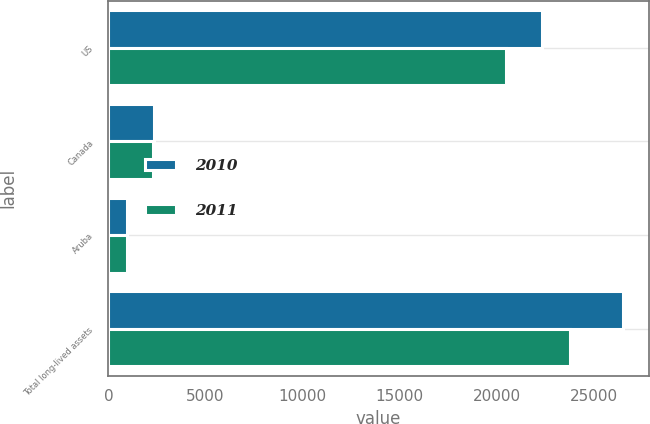<chart> <loc_0><loc_0><loc_500><loc_500><stacked_bar_chart><ecel><fcel>US<fcel>Canada<fcel>Aruba<fcel>Total long-lived assets<nl><fcel>2010<fcel>22317<fcel>2362<fcel>958<fcel>26485<nl><fcel>2011<fcel>20488<fcel>2308<fcel>981<fcel>23777<nl></chart> 